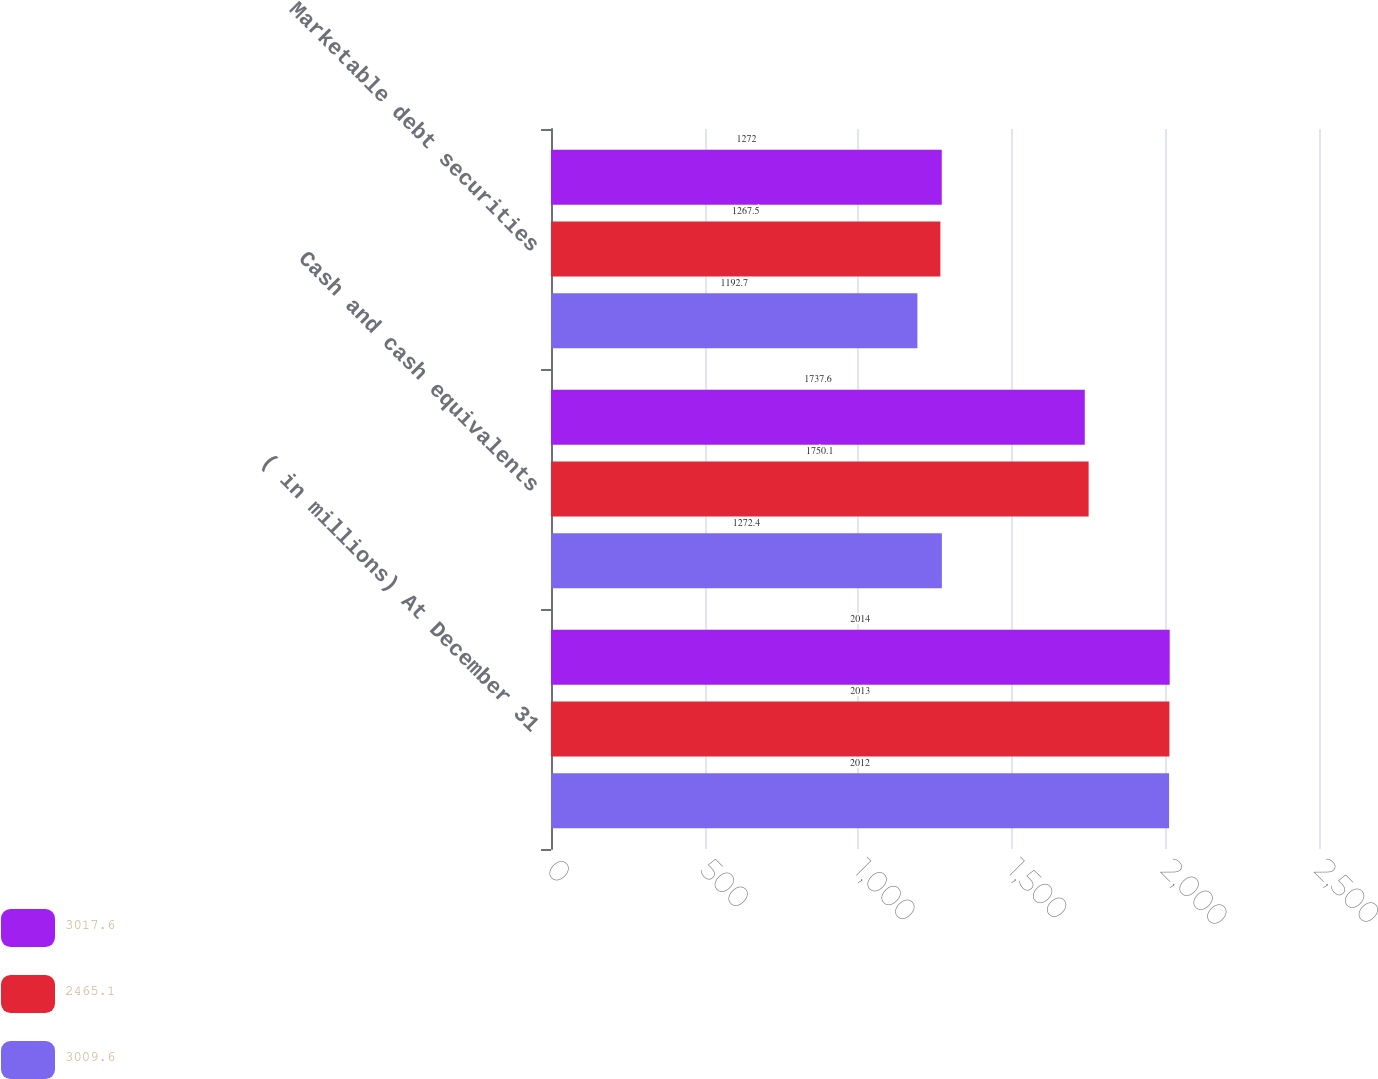Convert chart. <chart><loc_0><loc_0><loc_500><loc_500><stacked_bar_chart><ecel><fcel>( in millions) At December 31<fcel>Cash and cash equivalents<fcel>Marketable debt securities<nl><fcel>3017.6<fcel>2014<fcel>1737.6<fcel>1272<nl><fcel>2465.1<fcel>2013<fcel>1750.1<fcel>1267.5<nl><fcel>3009.6<fcel>2012<fcel>1272.4<fcel>1192.7<nl></chart> 